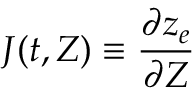<formula> <loc_0><loc_0><loc_500><loc_500>J ( t , Z ) \equiv \frac { \partial z _ { e } } { \partial Z }</formula> 